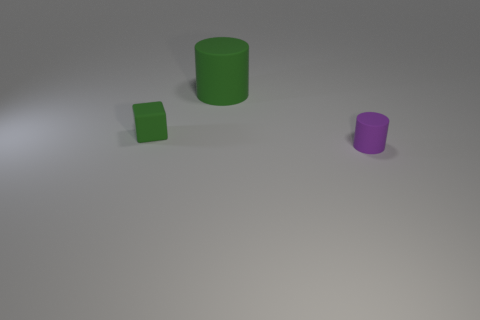There is a object that is both in front of the big rubber object and to the right of the small green cube; what material is it?
Make the answer very short. Rubber. Does the large rubber thing have the same color as the small thing that is behind the tiny purple rubber thing?
Your answer should be compact. Yes. Is the shape of the thing right of the green cylinder the same as the green rubber thing behind the small green rubber block?
Offer a very short reply. Yes. Are there an equal number of small things on the right side of the tiny purple cylinder and green rubber things?
Provide a succinct answer. No. What number of blue cylinders have the same material as the green block?
Keep it short and to the point. 0. What color is the tiny cylinder that is the same material as the green block?
Keep it short and to the point. Purple. There is a purple cylinder; does it have the same size as the green matte object that is on the left side of the large thing?
Provide a succinct answer. Yes. The tiny purple object is what shape?
Offer a terse response. Cylinder. How many large things have the same color as the cube?
Your answer should be compact. 1. There is another matte object that is the same shape as the large green matte thing; what is its color?
Ensure brevity in your answer.  Purple. 